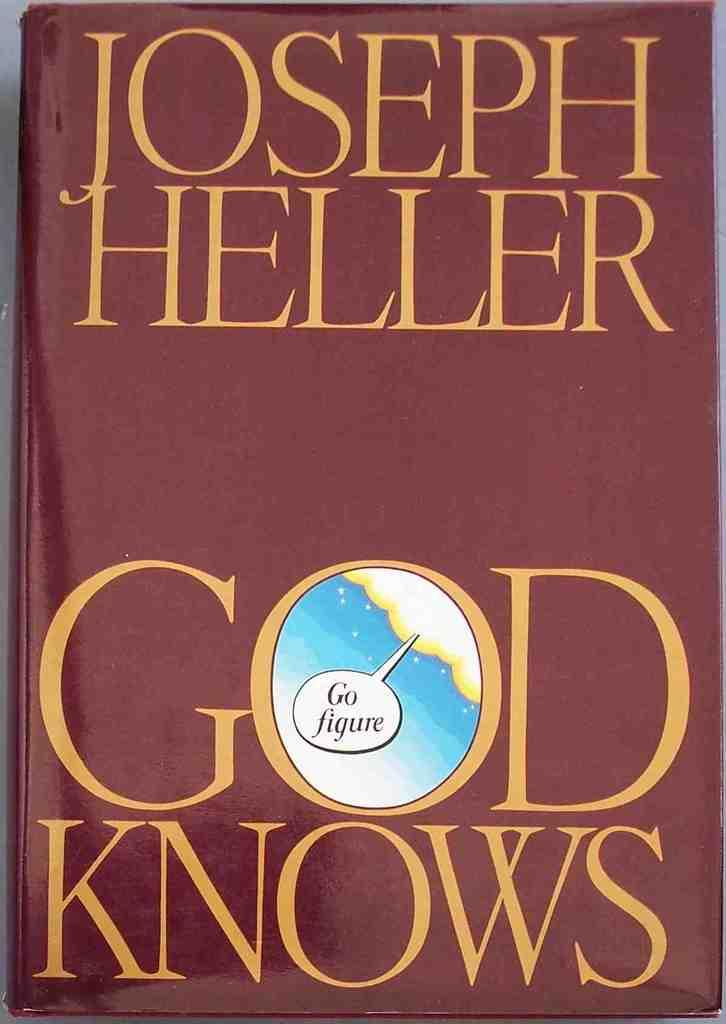<image>
Render a clear and concise summary of the photo. Red book cover for God Knows by Joseph Heller. 